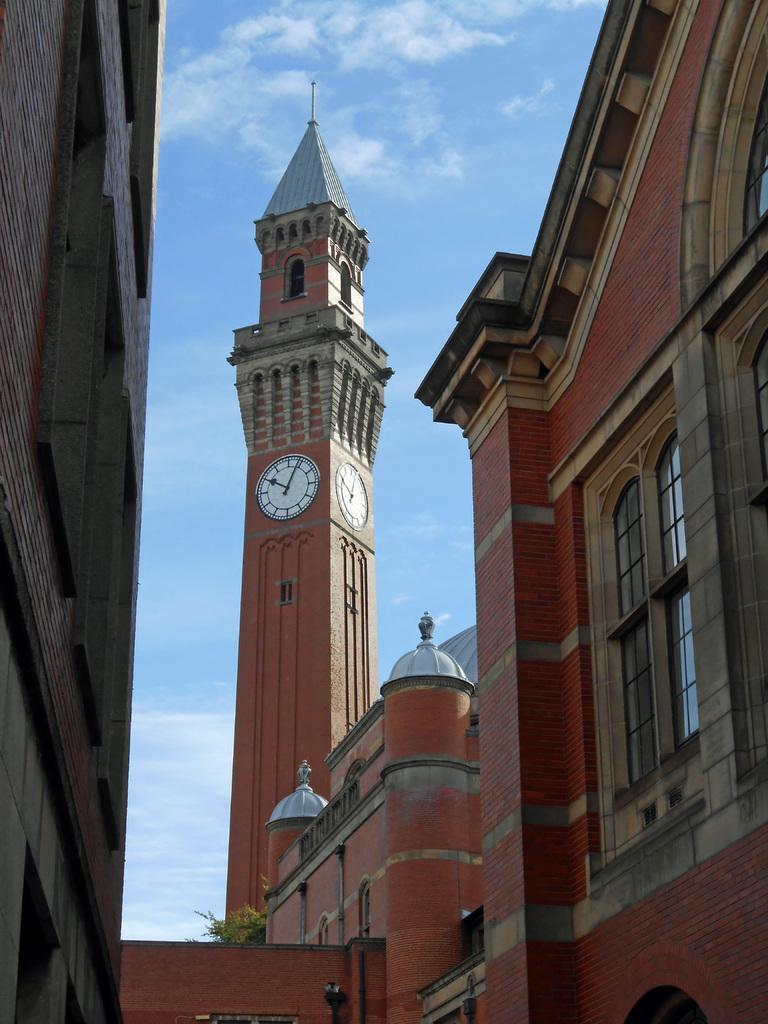Can you describe this image briefly? There is a tall tower with a clock on it. On either side there are some buildings located. There is a window for these building. In the background we can observe a sky and clouds too. 